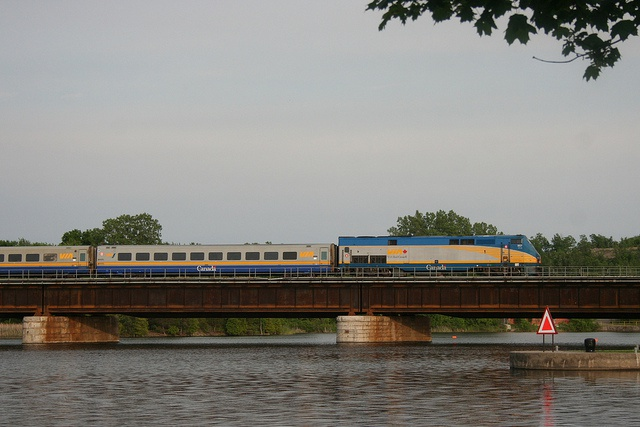Describe the objects in this image and their specific colors. I can see a train in darkgray, black, and gray tones in this image. 